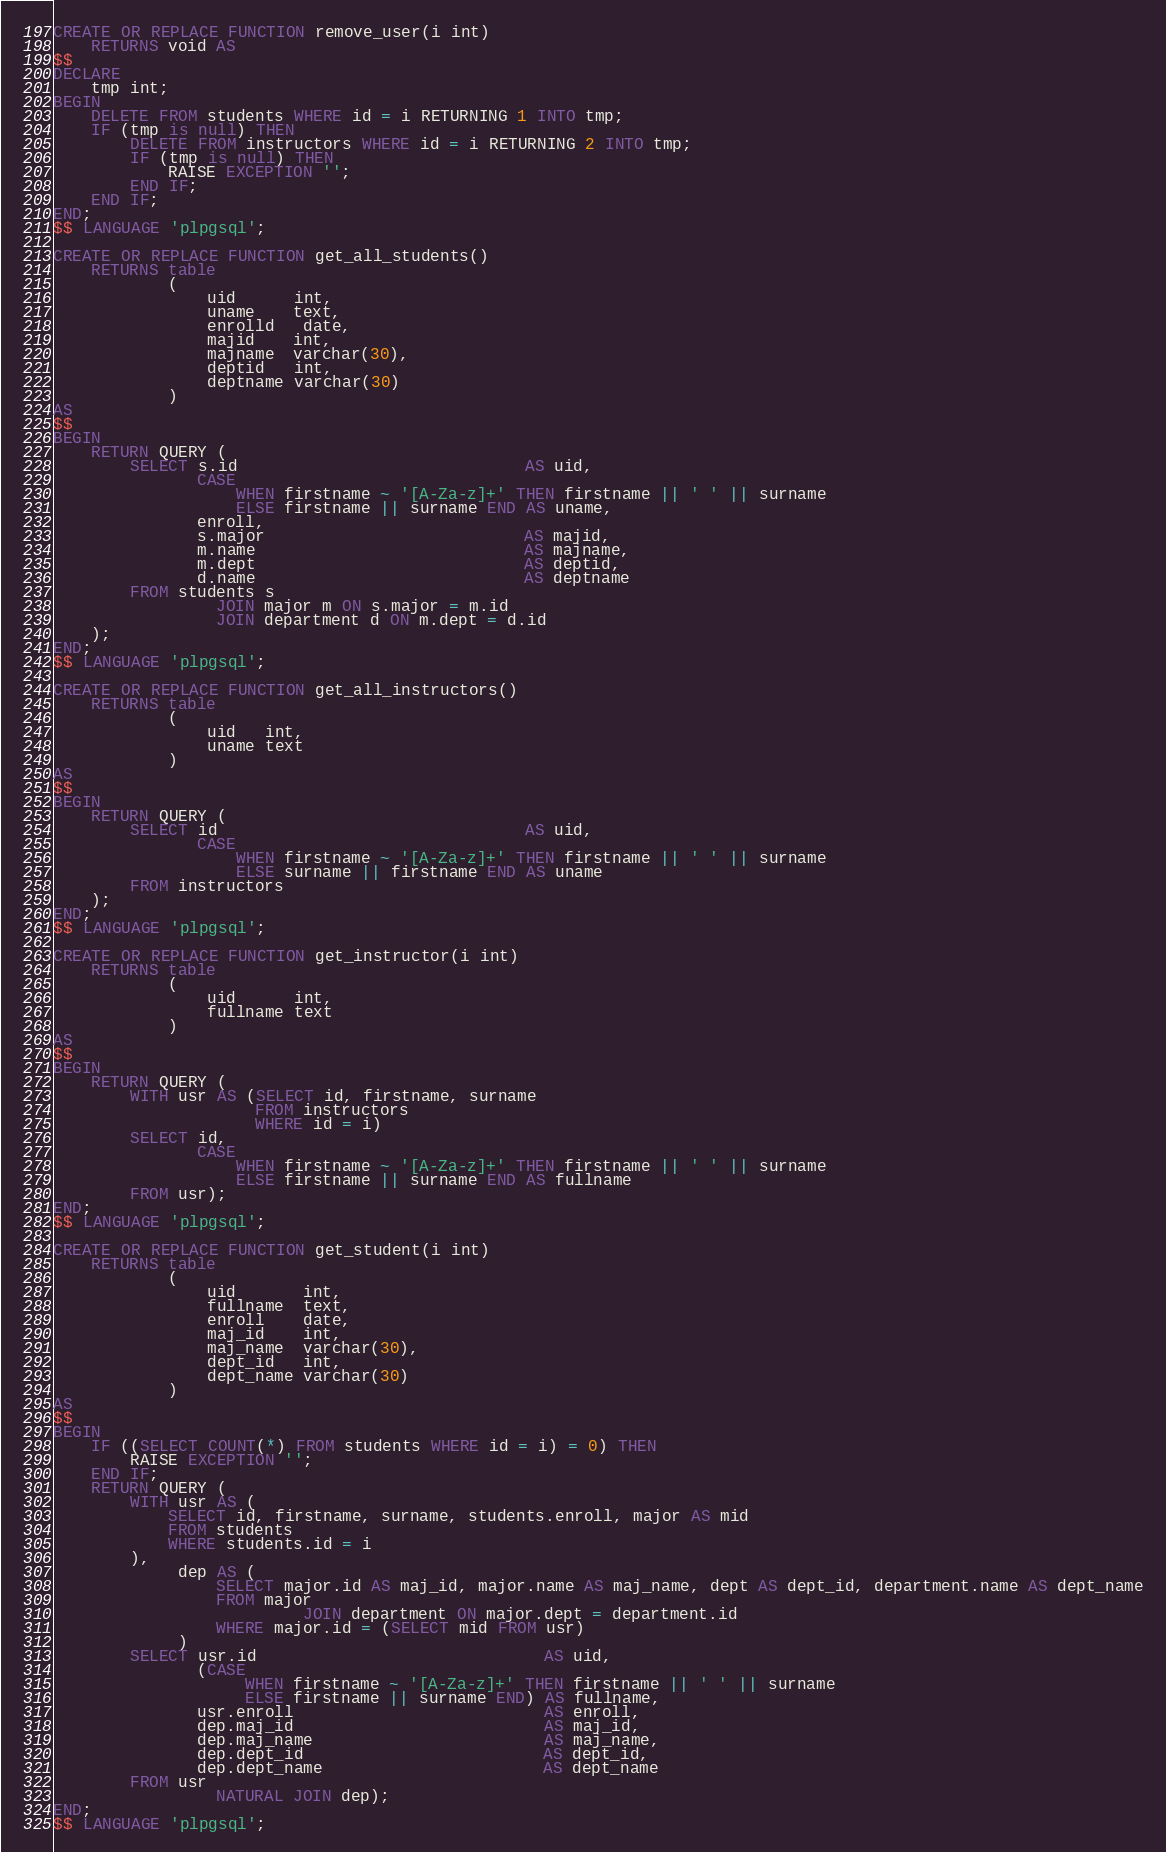Convert code to text. <code><loc_0><loc_0><loc_500><loc_500><_SQL_>CREATE OR REPLACE FUNCTION remove_user(i int)
    RETURNS void AS
$$
DECLARE
    tmp int;
BEGIN
    DELETE FROM students WHERE id = i RETURNING 1 INTO tmp;
    IF (tmp is null) THEN
        DELETE FROM instructors WHERE id = i RETURNING 2 INTO tmp;
        IF (tmp is null) THEN
            RAISE EXCEPTION '';
        END IF;
    END IF;
END;
$$ LANGUAGE 'plpgsql';

CREATE OR REPLACE FUNCTION get_all_students()
    RETURNS table
            (
                uid      int,
                uname    text,
                enrolld   date,
                majid    int,
                majname  varchar(30),
                deptid   int,
                deptname varchar(30)
            )
AS
$$
BEGIN
    RETURN QUERY (
        SELECT s.id                              AS uid,
               CASE
                   WHEN firstname ~ '[A-Za-z]+' THEN firstname || ' ' || surname
                   ELSE firstname || surname END AS uname,
               enroll,
               s.major                           AS majid,
               m.name                            AS majname,
               m.dept                            AS deptid,
               d.name                            AS deptname
        FROM students s
                 JOIN major m ON s.major = m.id
                 JOIN department d ON m.dept = d.id
    );
END;
$$ LANGUAGE 'plpgsql';

CREATE OR REPLACE FUNCTION get_all_instructors()
    RETURNS table
            (
                uid   int,
                uname text
            )
AS
$$
BEGIN
    RETURN QUERY (
        SELECT id                                AS uid,
               CASE
                   WHEN firstname ~ '[A-Za-z]+' THEN firstname || ' ' || surname
                   ELSE surname || firstname END AS uname
        FROM instructors
    );
END;
$$ LANGUAGE 'plpgsql';

CREATE OR REPLACE FUNCTION get_instructor(i int)
    RETURNS table
            (
                uid      int,
                fullname text
            )
AS
$$
BEGIN
    RETURN QUERY (
        WITH usr AS (SELECT id, firstname, surname
                     FROM instructors
                     WHERE id = i)
        SELECT id,
               CASE
                   WHEN firstname ~ '[A-Za-z]+' THEN firstname || ' ' || surname
                   ELSE firstname || surname END AS fullname
        FROM usr);
END;
$$ LANGUAGE 'plpgsql';

CREATE OR REPLACE FUNCTION get_student(i int)
    RETURNS table
            (
                uid       int,
                fullname  text,
                enroll    date,
                maj_id    int,
                maj_name  varchar(30),
                dept_id   int,
                dept_name varchar(30)
            )
AS
$$
BEGIN
    IF ((SELECT COUNT(*) FROM students WHERE id = i) = 0) THEN
        RAISE EXCEPTION '';
    END IF;
    RETURN QUERY (
        WITH usr AS (
            SELECT id, firstname, surname, students.enroll, major AS mid
            FROM students
            WHERE students.id = i
        ),
             dep AS (
                 SELECT major.id AS maj_id, major.name AS maj_name, dept AS dept_id, department.name AS dept_name
                 FROM major
                          JOIN department ON major.dept = department.id
                 WHERE major.id = (SELECT mid FROM usr)
             )
        SELECT usr.id                              AS uid,
               (CASE
                    WHEN firstname ~ '[A-Za-z]+' THEN firstname || ' ' || surname
                    ELSE firstname || surname END) AS fullname,
               usr.enroll                          AS enroll,
               dep.maj_id                          AS maj_id,
               dep.maj_name                        AS maj_name,
               dep.dept_id                         AS dept_id,
               dep.dept_name                       AS dept_name
        FROM usr
                 NATURAL JOIN dep);
END;
$$ LANGUAGE 'plpgsql';
</code> 